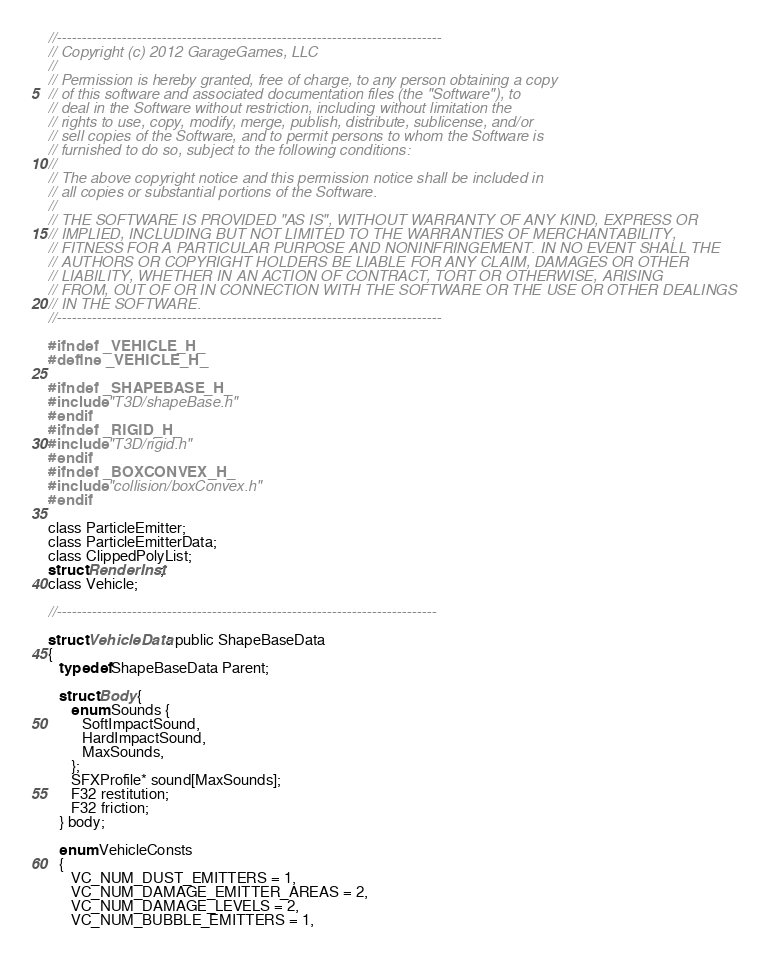<code> <loc_0><loc_0><loc_500><loc_500><_C_>//-----------------------------------------------------------------------------
// Copyright (c) 2012 GarageGames, LLC
//
// Permission is hereby granted, free of charge, to any person obtaining a copy
// of this software and associated documentation files (the "Software"), to
// deal in the Software without restriction, including without limitation the
// rights to use, copy, modify, merge, publish, distribute, sublicense, and/or
// sell copies of the Software, and to permit persons to whom the Software is
// furnished to do so, subject to the following conditions:
//
// The above copyright notice and this permission notice shall be included in
// all copies or substantial portions of the Software.
//
// THE SOFTWARE IS PROVIDED "AS IS", WITHOUT WARRANTY OF ANY KIND, EXPRESS OR
// IMPLIED, INCLUDING BUT NOT LIMITED TO THE WARRANTIES OF MERCHANTABILITY,
// FITNESS FOR A PARTICULAR PURPOSE AND NONINFRINGEMENT. IN NO EVENT SHALL THE
// AUTHORS OR COPYRIGHT HOLDERS BE LIABLE FOR ANY CLAIM, DAMAGES OR OTHER
// LIABILITY, WHETHER IN AN ACTION OF CONTRACT, TORT OR OTHERWISE, ARISING
// FROM, OUT OF OR IN CONNECTION WITH THE SOFTWARE OR THE USE OR OTHER DEALINGS
// IN THE SOFTWARE.
//-----------------------------------------------------------------------------

#ifndef _VEHICLE_H_
#define _VEHICLE_H_

#ifndef _SHAPEBASE_H_
#include "T3D/shapeBase.h"
#endif
#ifndef _RIGID_H_
#include "T3D/rigid.h"
#endif
#ifndef _BOXCONVEX_H_
#include "collision/boxConvex.h"
#endif

class ParticleEmitter;
class ParticleEmitterData;
class ClippedPolyList;
struct RenderInst;
class Vehicle;

//----------------------------------------------------------------------------

struct VehicleData: public ShapeBaseData
{
   typedef ShapeBaseData Parent;

   struct Body {
      enum Sounds {
         SoftImpactSound,
         HardImpactSound,
         MaxSounds,
      };
      SFXProfile* sound[MaxSounds];
      F32 restitution;
      F32 friction;
   } body;

   enum VehicleConsts
   {
      VC_NUM_DUST_EMITTERS = 1,
      VC_NUM_DAMAGE_EMITTER_AREAS = 2,
      VC_NUM_DAMAGE_LEVELS = 2,
      VC_NUM_BUBBLE_EMITTERS = 1,</code> 